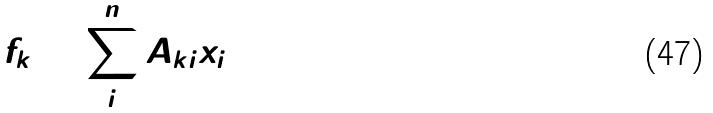Convert formula to latex. <formula><loc_0><loc_0><loc_500><loc_500>f _ { k } = \sum _ { i } ^ { n } A _ { k i } x _ { i }</formula> 